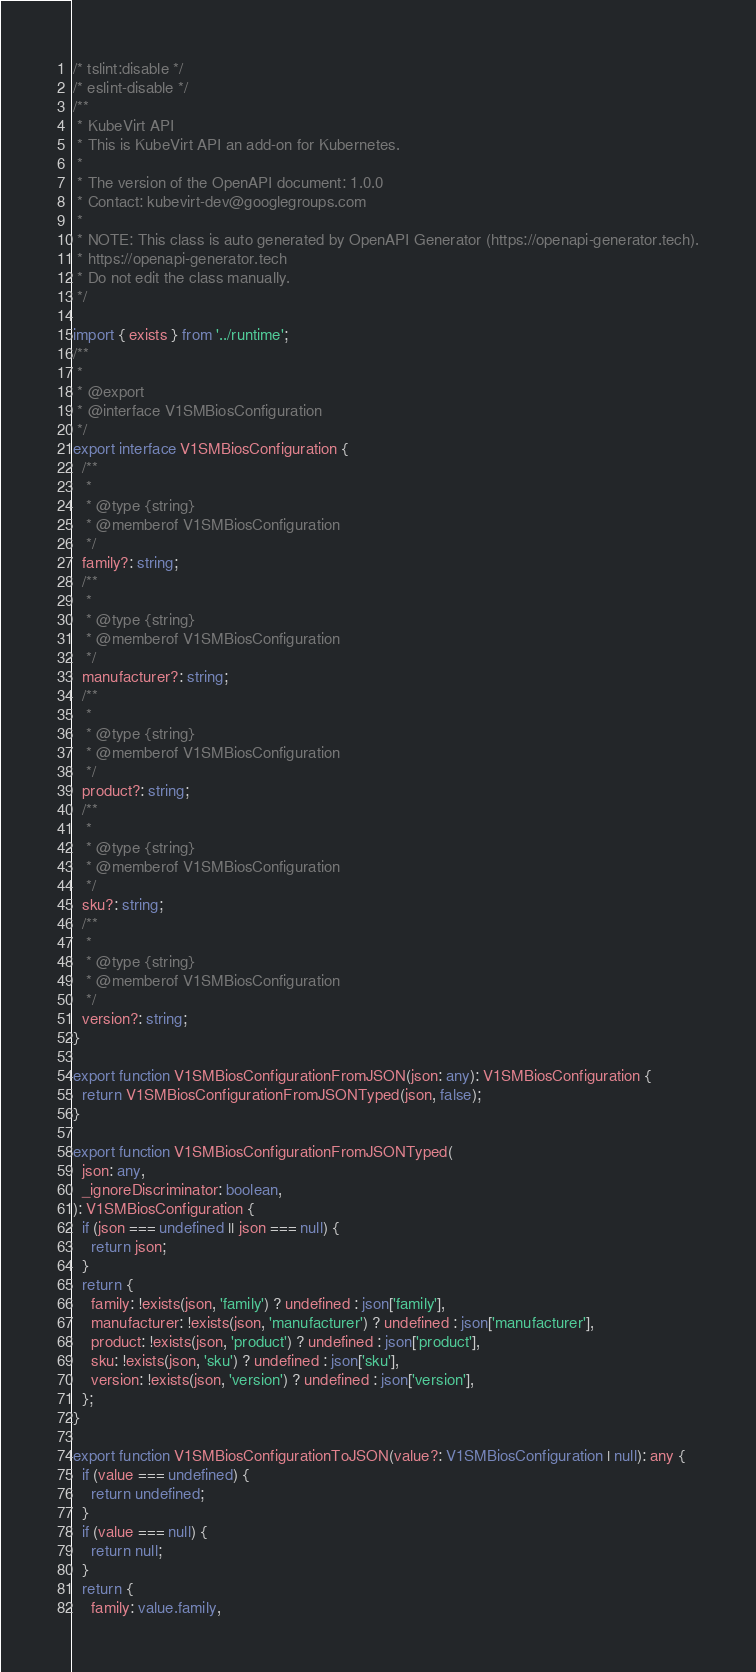Convert code to text. <code><loc_0><loc_0><loc_500><loc_500><_TypeScript_>/* tslint:disable */
/* eslint-disable */
/**
 * KubeVirt API
 * This is KubeVirt API an add-on for Kubernetes.
 *
 * The version of the OpenAPI document: 1.0.0
 * Contact: kubevirt-dev@googlegroups.com
 *
 * NOTE: This class is auto generated by OpenAPI Generator (https://openapi-generator.tech).
 * https://openapi-generator.tech
 * Do not edit the class manually.
 */

import { exists } from '../runtime';
/**
 *
 * @export
 * @interface V1SMBiosConfiguration
 */
export interface V1SMBiosConfiguration {
  /**
   *
   * @type {string}
   * @memberof V1SMBiosConfiguration
   */
  family?: string;
  /**
   *
   * @type {string}
   * @memberof V1SMBiosConfiguration
   */
  manufacturer?: string;
  /**
   *
   * @type {string}
   * @memberof V1SMBiosConfiguration
   */
  product?: string;
  /**
   *
   * @type {string}
   * @memberof V1SMBiosConfiguration
   */
  sku?: string;
  /**
   *
   * @type {string}
   * @memberof V1SMBiosConfiguration
   */
  version?: string;
}

export function V1SMBiosConfigurationFromJSON(json: any): V1SMBiosConfiguration {
  return V1SMBiosConfigurationFromJSONTyped(json, false);
}

export function V1SMBiosConfigurationFromJSONTyped(
  json: any,
  _ignoreDiscriminator: boolean,
): V1SMBiosConfiguration {
  if (json === undefined || json === null) {
    return json;
  }
  return {
    family: !exists(json, 'family') ? undefined : json['family'],
    manufacturer: !exists(json, 'manufacturer') ? undefined : json['manufacturer'],
    product: !exists(json, 'product') ? undefined : json['product'],
    sku: !exists(json, 'sku') ? undefined : json['sku'],
    version: !exists(json, 'version') ? undefined : json['version'],
  };
}

export function V1SMBiosConfigurationToJSON(value?: V1SMBiosConfiguration | null): any {
  if (value === undefined) {
    return undefined;
  }
  if (value === null) {
    return null;
  }
  return {
    family: value.family,</code> 